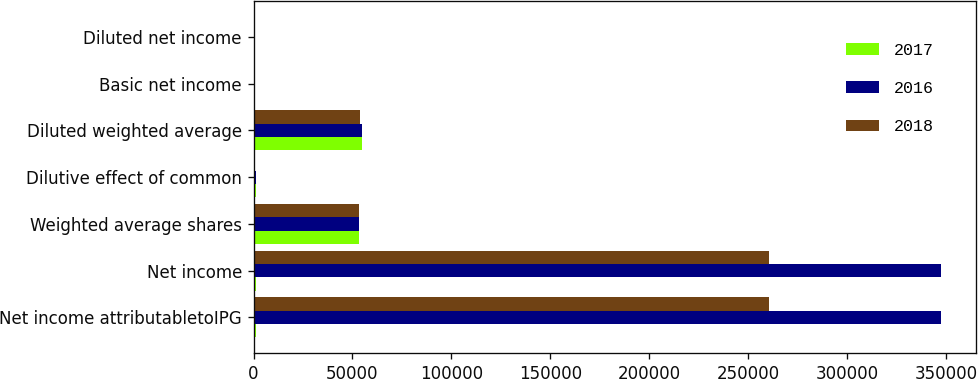<chart> <loc_0><loc_0><loc_500><loc_500><stacked_bar_chart><ecel><fcel>Net income attributabletoIPG<fcel>Net income<fcel>Weighted average shares<fcel>Dilutive effect of common<fcel>Diluted weighted average<fcel>Basic net income<fcel>Diluted net income<nl><fcel>2017<fcel>1204<fcel>1204<fcel>53522<fcel>1204<fcel>54726<fcel>7.55<fcel>7.38<nl><fcel>2016<fcel>347614<fcel>347614<fcel>53495<fcel>1204<fcel>54699<fcel>6.5<fcel>6.36<nl><fcel>2018<fcel>260752<fcel>260752<fcel>53068<fcel>729<fcel>53797<fcel>4.91<fcel>4.85<nl></chart> 